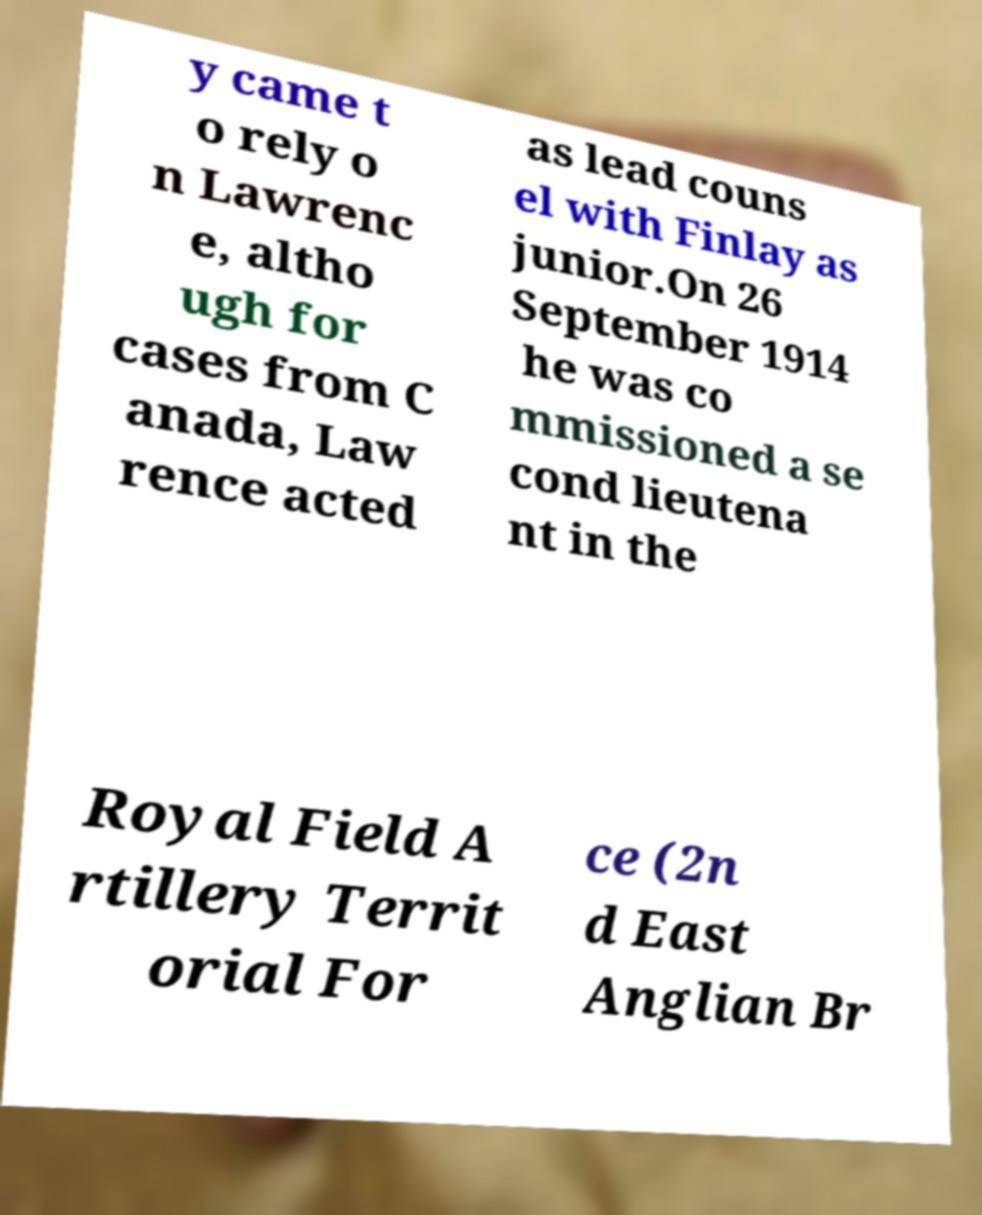Could you extract and type out the text from this image? y came t o rely o n Lawrenc e, altho ugh for cases from C anada, Law rence acted as lead couns el with Finlay as junior.On 26 September 1914 he was co mmissioned a se cond lieutena nt in the Royal Field A rtillery Territ orial For ce (2n d East Anglian Br 